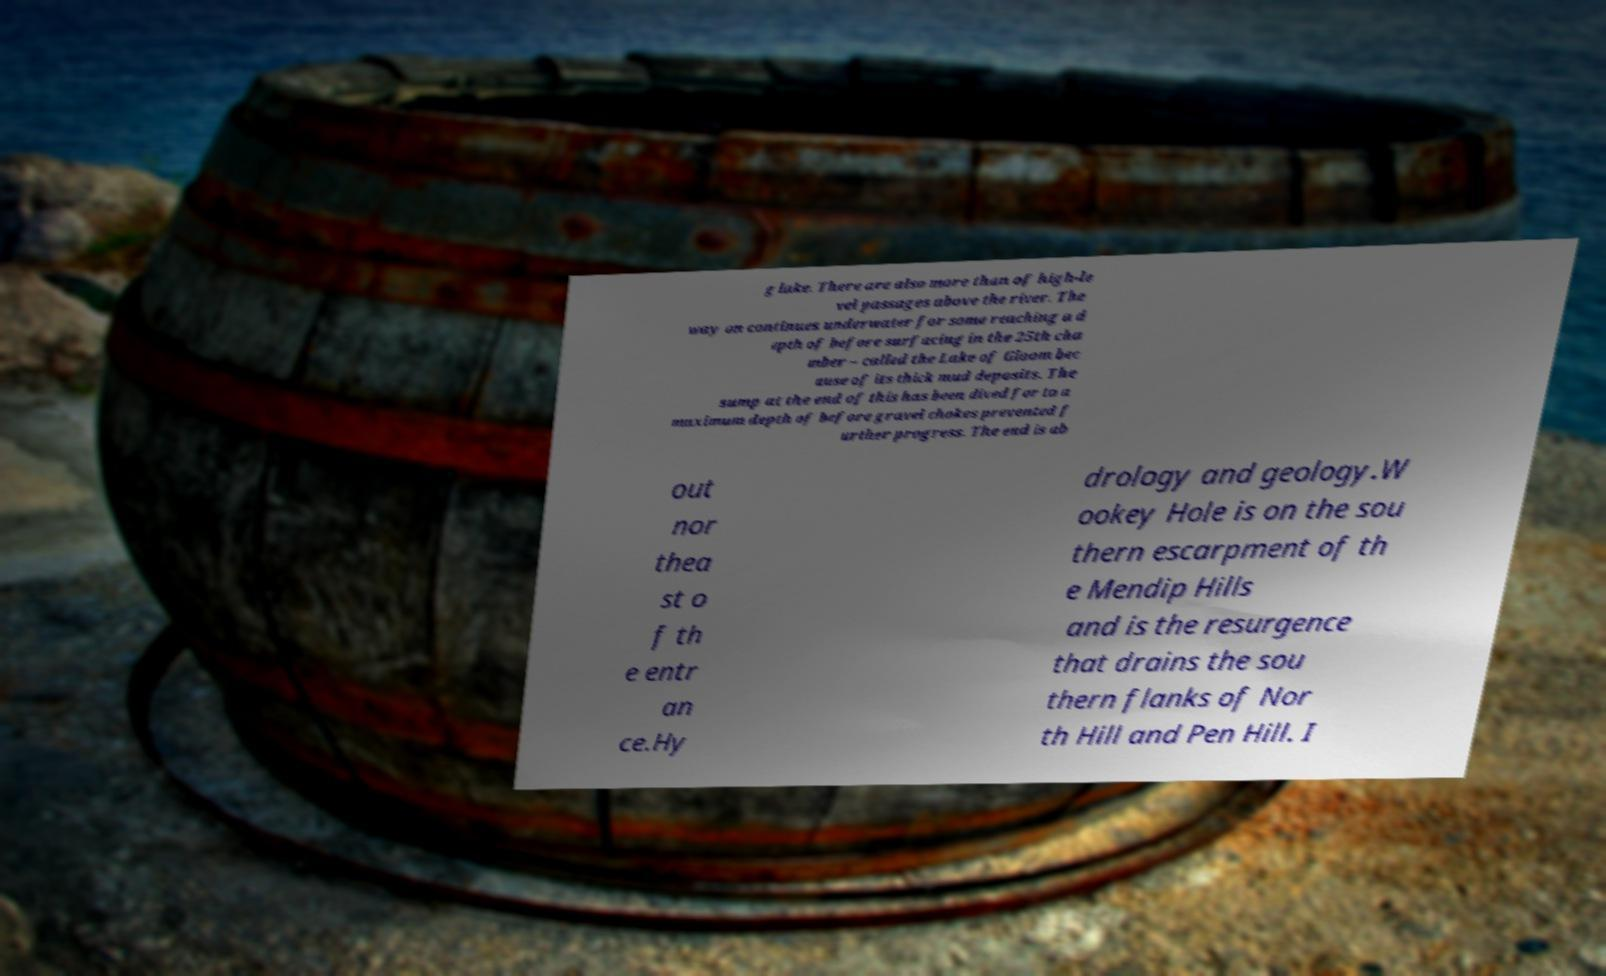What messages or text are displayed in this image? I need them in a readable, typed format. g lake. There are also more than of high-le vel passages above the river. The way on continues underwater for some reaching a d epth of before surfacing in the 25th cha mber – called the Lake of Gloom bec ause of its thick mud deposits. The sump at the end of this has been dived for to a maximum depth of before gravel chokes prevented f urther progress. The end is ab out nor thea st o f th e entr an ce.Hy drology and geology.W ookey Hole is on the sou thern escarpment of th e Mendip Hills and is the resurgence that drains the sou thern flanks of Nor th Hill and Pen Hill. I 